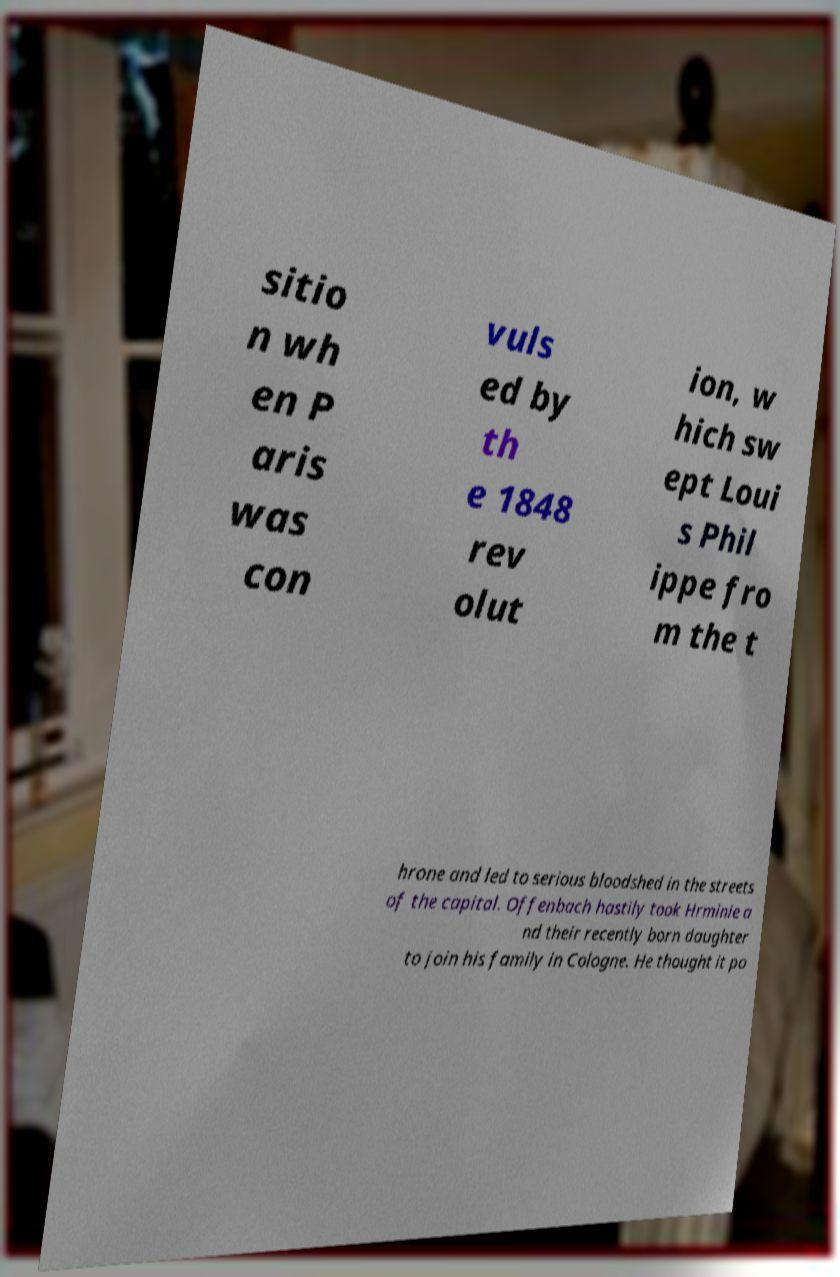There's text embedded in this image that I need extracted. Can you transcribe it verbatim? sitio n wh en P aris was con vuls ed by th e 1848 rev olut ion, w hich sw ept Loui s Phil ippe fro m the t hrone and led to serious bloodshed in the streets of the capital. Offenbach hastily took Hrminie a nd their recently born daughter to join his family in Cologne. He thought it po 